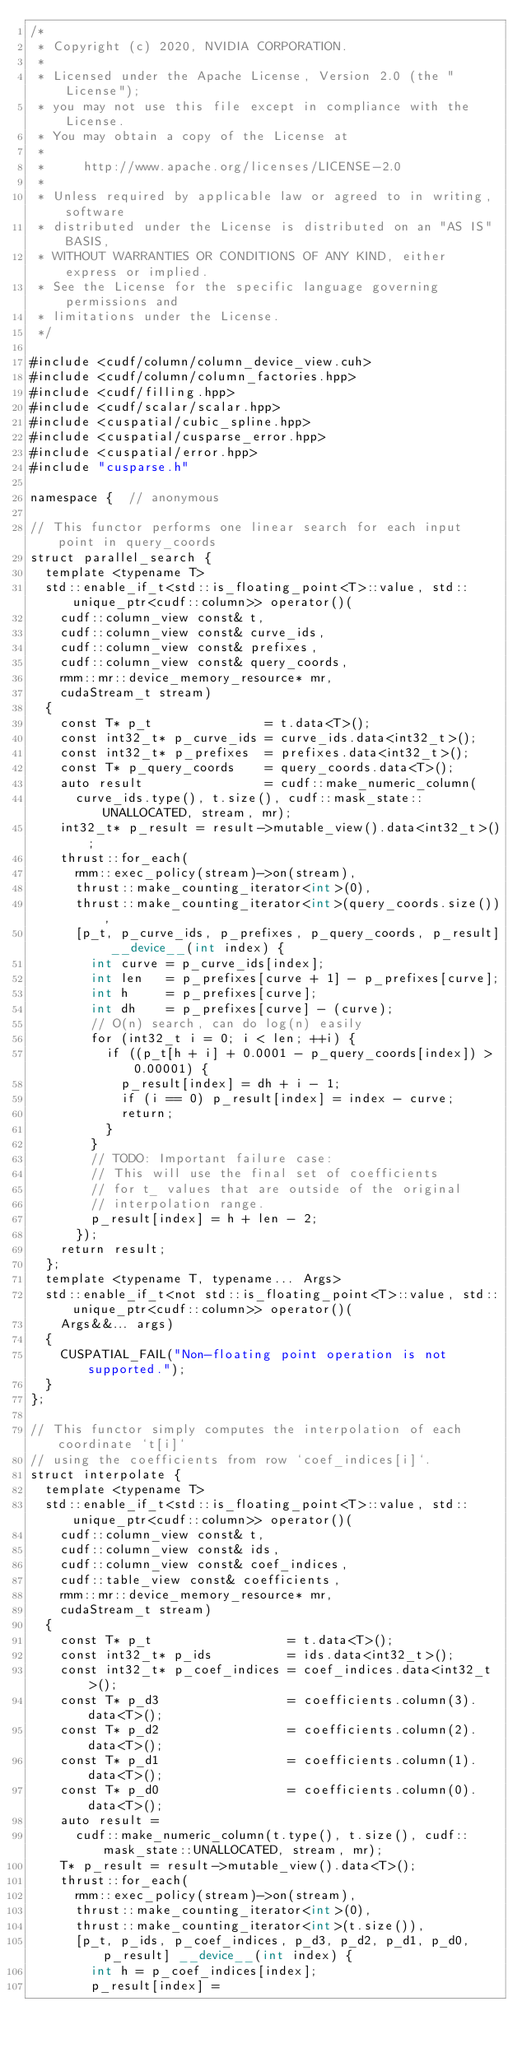Convert code to text. <code><loc_0><loc_0><loc_500><loc_500><_Cuda_>/*
 * Copyright (c) 2020, NVIDIA CORPORATION.
 *
 * Licensed under the Apache License, Version 2.0 (the "License");
 * you may not use this file except in compliance with the License.
 * You may obtain a copy of the License at
 *
 *     http://www.apache.org/licenses/LICENSE-2.0
 *
 * Unless required by applicable law or agreed to in writing, software
 * distributed under the License is distributed on an "AS IS" BASIS,
 * WITHOUT WARRANTIES OR CONDITIONS OF ANY KIND, either express or implied.
 * See the License for the specific language governing permissions and
 * limitations under the License.
 */

#include <cudf/column/column_device_view.cuh>
#include <cudf/column/column_factories.hpp>
#include <cudf/filling.hpp>
#include <cudf/scalar/scalar.hpp>
#include <cuspatial/cubic_spline.hpp>
#include <cuspatial/cusparse_error.hpp>
#include <cuspatial/error.hpp>
#include "cusparse.h"

namespace {  // anonymous

// This functor performs one linear search for each input point in query_coords
struct parallel_search {
  template <typename T>
  std::enable_if_t<std::is_floating_point<T>::value, std::unique_ptr<cudf::column>> operator()(
    cudf::column_view const& t,
    cudf::column_view const& curve_ids,
    cudf::column_view const& prefixes,
    cudf::column_view const& query_coords,
    rmm::mr::device_memory_resource* mr,
    cudaStream_t stream)
  {
    const T* p_t               = t.data<T>();
    const int32_t* p_curve_ids = curve_ids.data<int32_t>();
    const int32_t* p_prefixes  = prefixes.data<int32_t>();
    const T* p_query_coords    = query_coords.data<T>();
    auto result                = cudf::make_numeric_column(
      curve_ids.type(), t.size(), cudf::mask_state::UNALLOCATED, stream, mr);
    int32_t* p_result = result->mutable_view().data<int32_t>();
    thrust::for_each(
      rmm::exec_policy(stream)->on(stream),
      thrust::make_counting_iterator<int>(0),
      thrust::make_counting_iterator<int>(query_coords.size()),
      [p_t, p_curve_ids, p_prefixes, p_query_coords, p_result] __device__(int index) {
        int curve = p_curve_ids[index];
        int len   = p_prefixes[curve + 1] - p_prefixes[curve];
        int h     = p_prefixes[curve];
        int dh    = p_prefixes[curve] - (curve);
        // O(n) search, can do log(n) easily
        for (int32_t i = 0; i < len; ++i) {
          if ((p_t[h + i] + 0.0001 - p_query_coords[index]) > 0.00001) {
            p_result[index] = dh + i - 1;
            if (i == 0) p_result[index] = index - curve;
            return;
          }
        }
        // TODO: Important failure case:
        // This will use the final set of coefficients
        // for t_ values that are outside of the original
        // interpolation range.
        p_result[index] = h + len - 2;
      });
    return result;
  };
  template <typename T, typename... Args>
  std::enable_if_t<not std::is_floating_point<T>::value, std::unique_ptr<cudf::column>> operator()(
    Args&&... args)
  {
    CUSPATIAL_FAIL("Non-floating point operation is not supported.");
  }
};

// This functor simply computes the interpolation of each coordinate `t[i]`
// using the coefficients from row `coef_indices[i]`.
struct interpolate {
  template <typename T>
  std::enable_if_t<std::is_floating_point<T>::value, std::unique_ptr<cudf::column>> operator()(
    cudf::column_view const& t,
    cudf::column_view const& ids,
    cudf::column_view const& coef_indices,
    cudf::table_view const& coefficients,
    rmm::mr::device_memory_resource* mr,
    cudaStream_t stream)
  {
    const T* p_t                  = t.data<T>();
    const int32_t* p_ids          = ids.data<int32_t>();
    const int32_t* p_coef_indices = coef_indices.data<int32_t>();
    const T* p_d3                 = coefficients.column(3).data<T>();
    const T* p_d2                 = coefficients.column(2).data<T>();
    const T* p_d1                 = coefficients.column(1).data<T>();
    const T* p_d0                 = coefficients.column(0).data<T>();
    auto result =
      cudf::make_numeric_column(t.type(), t.size(), cudf::mask_state::UNALLOCATED, stream, mr);
    T* p_result = result->mutable_view().data<T>();
    thrust::for_each(
      rmm::exec_policy(stream)->on(stream),
      thrust::make_counting_iterator<int>(0),
      thrust::make_counting_iterator<int>(t.size()),
      [p_t, p_ids, p_coef_indices, p_d3, p_d2, p_d1, p_d0, p_result] __device__(int index) {
        int h = p_coef_indices[index];
        p_result[index] =</code> 